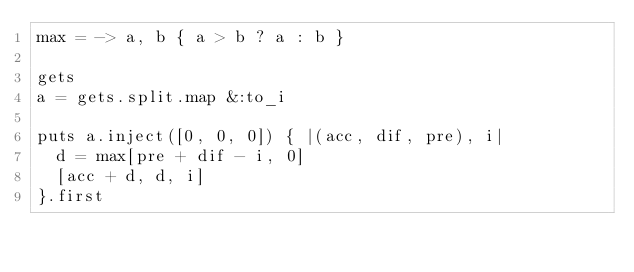<code> <loc_0><loc_0><loc_500><loc_500><_Ruby_>max = -> a, b { a > b ? a : b }

gets
a = gets.split.map &:to_i

puts a.inject([0, 0, 0]) { |(acc, dif, pre), i|
  d = max[pre + dif - i, 0]
  [acc + d, d, i]
}.first</code> 